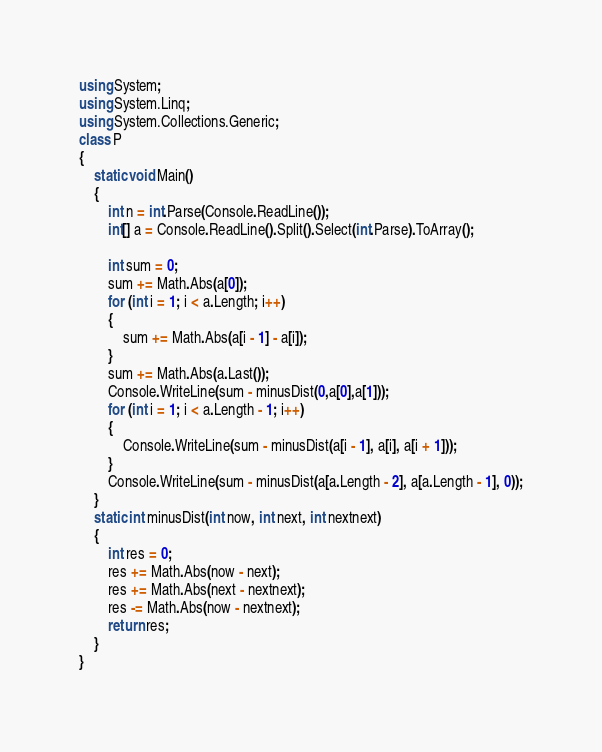Convert code to text. <code><loc_0><loc_0><loc_500><loc_500><_C#_>using System;
using System.Linq;
using System.Collections.Generic;
class P
{
    static void Main()
    {
        int n = int.Parse(Console.ReadLine());
        int[] a = Console.ReadLine().Split().Select(int.Parse).ToArray();

        int sum = 0;
        sum += Math.Abs(a[0]);
        for (int i = 1; i < a.Length; i++)
        {
            sum += Math.Abs(a[i - 1] - a[i]);
        }
        sum += Math.Abs(a.Last());
        Console.WriteLine(sum - minusDist(0,a[0],a[1]));
        for (int i = 1; i < a.Length - 1; i++)
        {
            Console.WriteLine(sum - minusDist(a[i - 1], a[i], a[i + 1]));
        }
        Console.WriteLine(sum - minusDist(a[a.Length - 2], a[a.Length - 1], 0));
    }
    static int minusDist(int now, int next, int nextnext)
    {
        int res = 0;
        res += Math.Abs(now - next);
        res += Math.Abs(next - nextnext);
        res -= Math.Abs(now - nextnext);
        return res;
    }
}</code> 